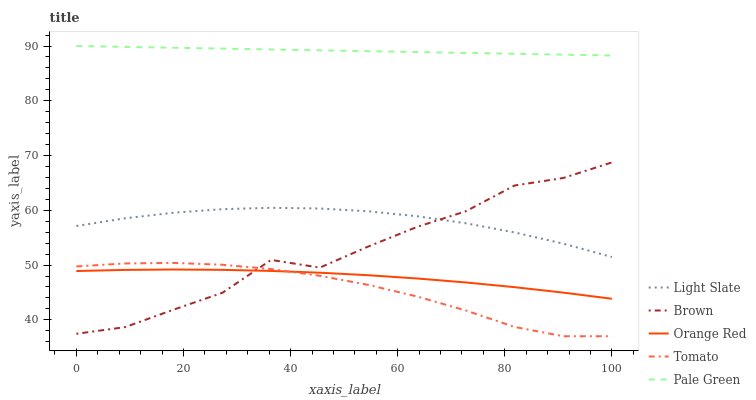Does Tomato have the minimum area under the curve?
Answer yes or no. Yes. Does Pale Green have the maximum area under the curve?
Answer yes or no. Yes. Does Brown have the minimum area under the curve?
Answer yes or no. No. Does Brown have the maximum area under the curve?
Answer yes or no. No. Is Pale Green the smoothest?
Answer yes or no. Yes. Is Brown the roughest?
Answer yes or no. Yes. Is Tomato the smoothest?
Answer yes or no. No. Is Tomato the roughest?
Answer yes or no. No. Does Tomato have the lowest value?
Answer yes or no. Yes. Does Brown have the lowest value?
Answer yes or no. No. Does Pale Green have the highest value?
Answer yes or no. Yes. Does Brown have the highest value?
Answer yes or no. No. Is Orange Red less than Pale Green?
Answer yes or no. Yes. Is Light Slate greater than Orange Red?
Answer yes or no. Yes. Does Light Slate intersect Brown?
Answer yes or no. Yes. Is Light Slate less than Brown?
Answer yes or no. No. Is Light Slate greater than Brown?
Answer yes or no. No. Does Orange Red intersect Pale Green?
Answer yes or no. No. 